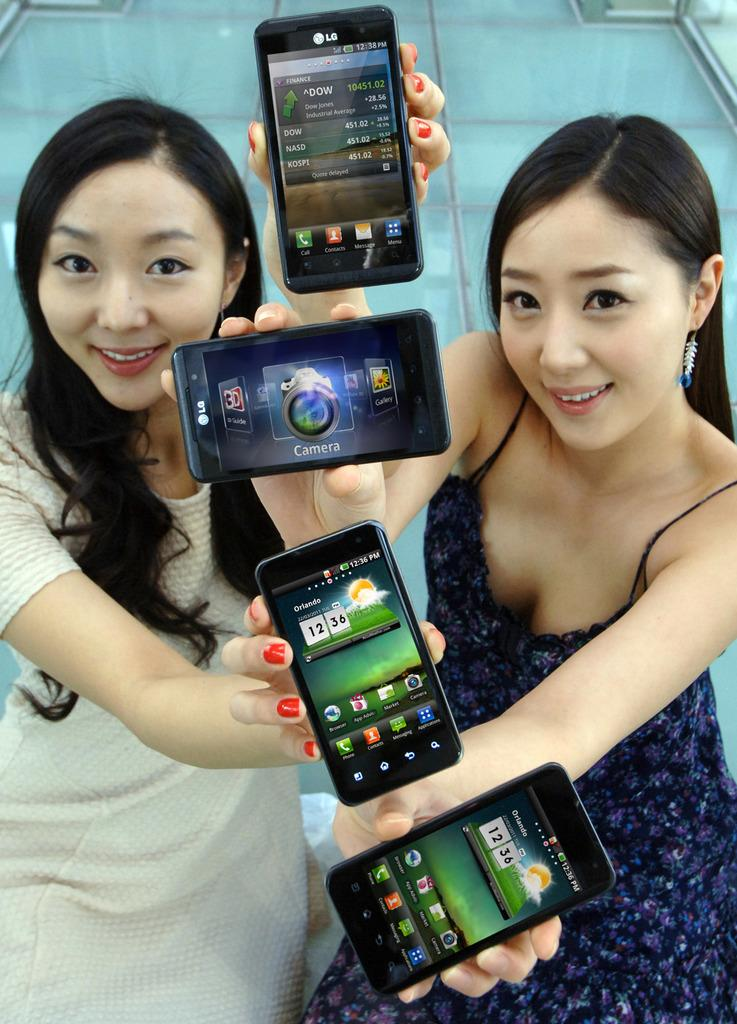Provide a one-sentence caption for the provided image. Two girls holding up four different devices, two are LGs and two are showing the weather for Orlando. 